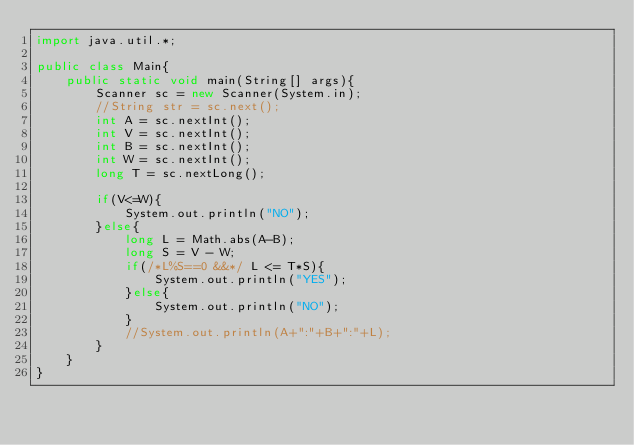Convert code to text. <code><loc_0><loc_0><loc_500><loc_500><_Java_>import java.util.*;

public class Main{
    public static void main(String[] args){
        Scanner sc = new Scanner(System.in);
        //String str = sc.next();
        int A = sc.nextInt();
        int V = sc.nextInt();
        int B = sc.nextInt();
        int W = sc.nextInt();
        long T = sc.nextLong();
        
        if(V<=W){
            System.out.println("NO");
        }else{
            long L = Math.abs(A-B);
            long S = V - W;
            if(/*L%S==0 &&*/ L <= T*S){
                System.out.println("YES");
            }else{
                System.out.println("NO");
            }
            //System.out.println(A+":"+B+":"+L);
        }
    }
}</code> 